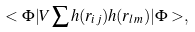Convert formula to latex. <formula><loc_0><loc_0><loc_500><loc_500>< \Phi | V \sum h ( r _ { i j } ) h ( r _ { l m } ) | \Phi > ,</formula> 